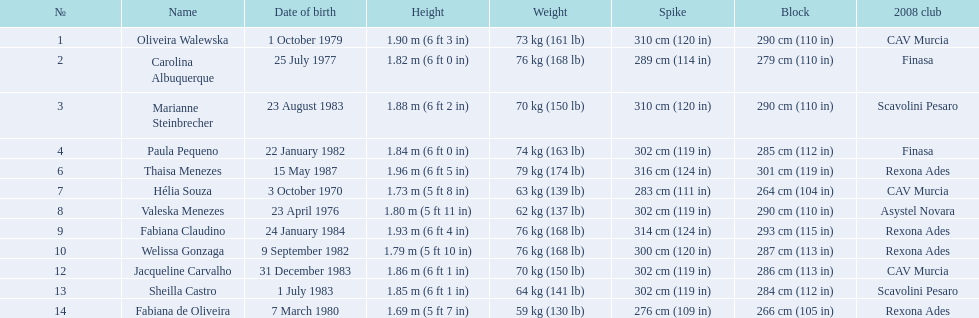What are the names of everyone? Oliveira Walewska, Carolina Albuquerque, Marianne Steinbrecher, Paula Pequeno, Thaisa Menezes, Hélia Souza, Valeska Menezes, Fabiana Claudino, Welissa Gonzaga, Jacqueline Carvalho, Sheilla Castro, Fabiana de Oliveira. What are their individual weights? 73 kg (161 lb), 76 kg (168 lb), 70 kg (150 lb), 74 kg (163 lb), 79 kg (174 lb), 63 kg (139 lb), 62 kg (137 lb), 76 kg (168 lb), 76 kg (168 lb), 70 kg (150 lb), 64 kg (141 lb), 59 kg (130 lb). How much did helia souza, fabiana de oliveira, and sheilla castro weigh? Hélia Souza, Sheilla Castro, Fabiana de Oliveira. Which one of them weighed the most? Sheilla Castro. 